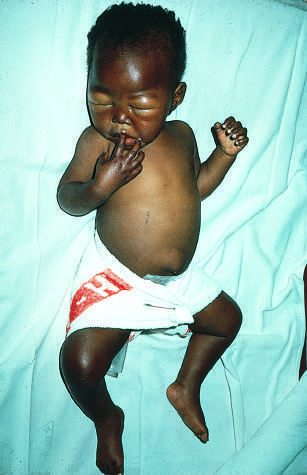what shows generalized edema, seen as ascites and puffiness of the face, hands, and legs?
Answer the question using a single word or phrase. The infant 